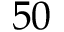<formula> <loc_0><loc_0><loc_500><loc_500>\, 5 0</formula> 